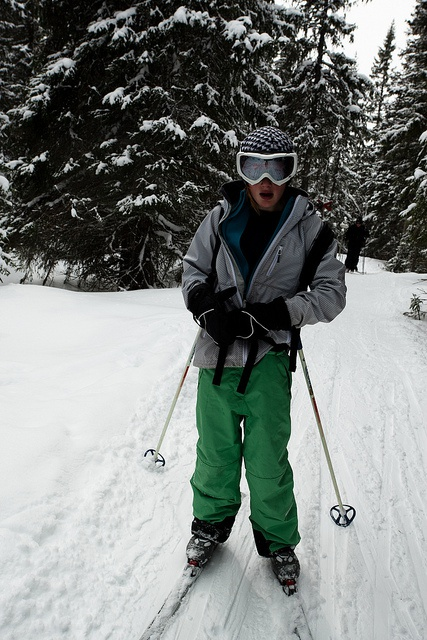Describe the objects in this image and their specific colors. I can see people in black, darkgreen, and gray tones, skis in black, darkgray, gray, and lightgray tones, people in black, gray, lightgray, and darkgray tones, and skis in black, darkgray, gray, and lightgray tones in this image. 